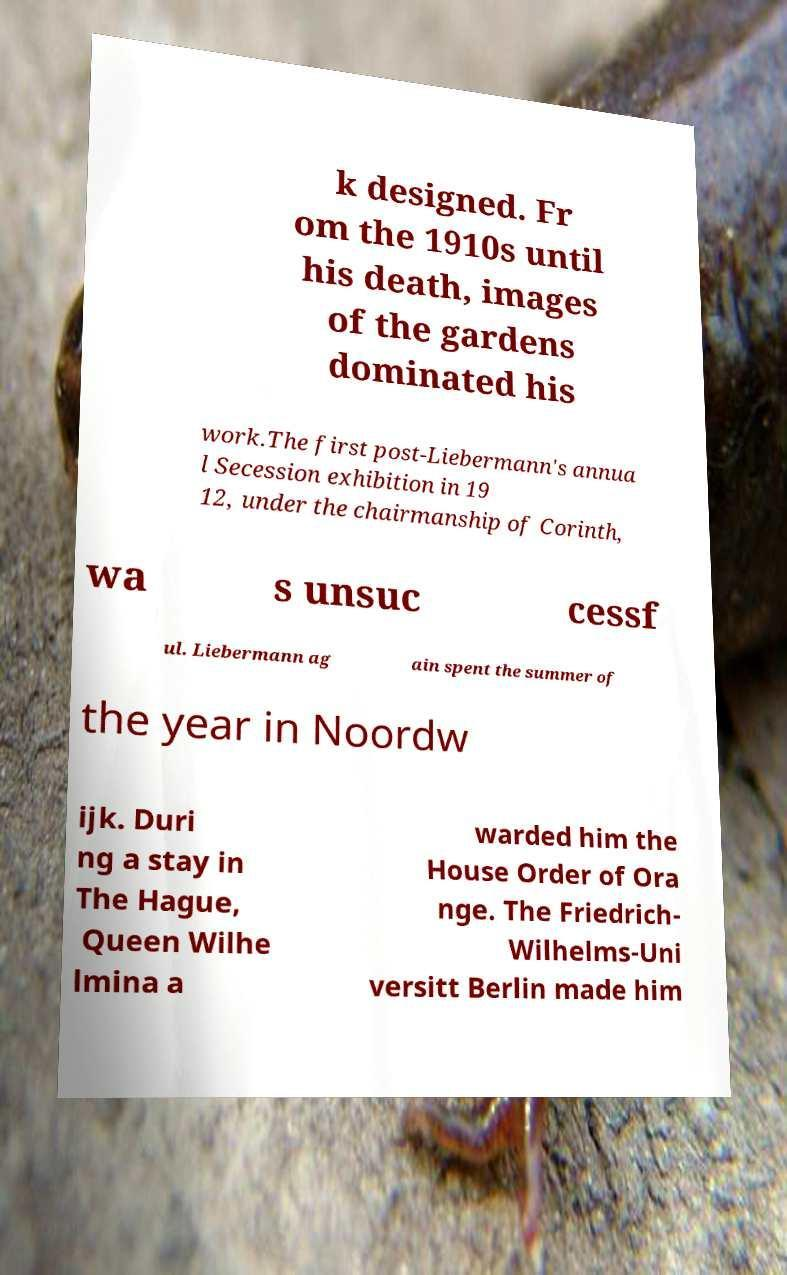Can you accurately transcribe the text from the provided image for me? k designed. Fr om the 1910s until his death, images of the gardens dominated his work.The first post-Liebermann's annua l Secession exhibition in 19 12, under the chairmanship of Corinth, wa s unsuc cessf ul. Liebermann ag ain spent the summer of the year in Noordw ijk. Duri ng a stay in The Hague, Queen Wilhe lmina a warded him the House Order of Ora nge. The Friedrich- Wilhelms-Uni versitt Berlin made him 